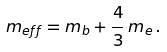<formula> <loc_0><loc_0><loc_500><loc_500>m _ { e f f } = m _ { b } + \frac { 4 } { 3 } \, m _ { e } \, .</formula> 